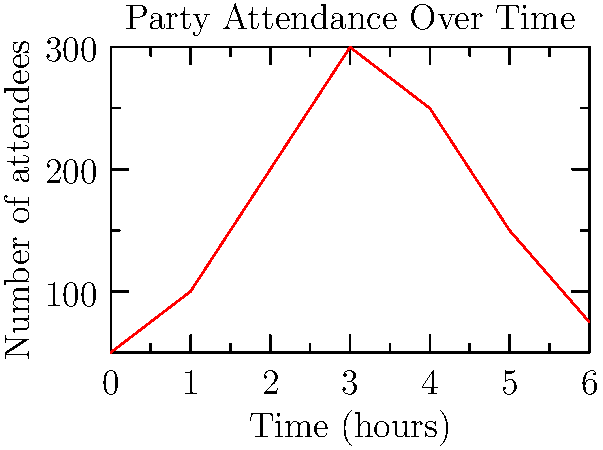Based on the graph showing party attendance over time at your rooftop bar, estimate the total number of drinks consumed during the 6-hour event if the average person drinks 2 beverages per hour. Assume a constant drinking rate throughout the party. To solve this problem, we need to follow these steps:

1. Calculate the average number of attendees over the 6-hour period:
   Sum of attendees at each hour: 50 + 100 + 200 + 300 + 250 + 150 + 75 = 1125
   Average attendees = 1125 ÷ 7 (data points) = 160.71

2. Determine the number of drinks consumed per person during the 6-hour event:
   Drinks per person = 2 drinks/hour × 6 hours = 12 drinks/person

3. Calculate the total number of drinks consumed:
   Total drinks = Average attendees × Drinks per person
   Total drinks = 160.71 × 12 = 1928.52

4. Round the result to the nearest whole number:
   1928.52 ≈ 1929 drinks
Answer: 1929 drinks 